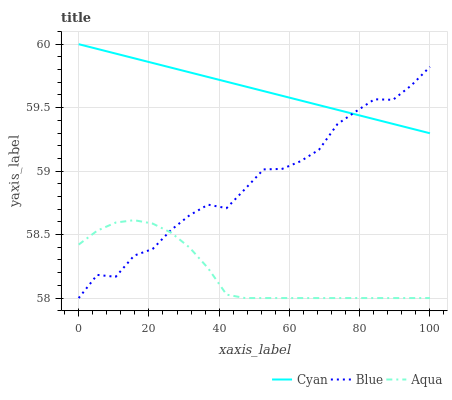Does Aqua have the minimum area under the curve?
Answer yes or no. Yes. Does Cyan have the maximum area under the curve?
Answer yes or no. Yes. Does Cyan have the minimum area under the curve?
Answer yes or no. No. Does Aqua have the maximum area under the curve?
Answer yes or no. No. Is Cyan the smoothest?
Answer yes or no. Yes. Is Blue the roughest?
Answer yes or no. Yes. Is Aqua the smoothest?
Answer yes or no. No. Is Aqua the roughest?
Answer yes or no. No. Does Blue have the lowest value?
Answer yes or no. Yes. Does Cyan have the lowest value?
Answer yes or no. No. Does Cyan have the highest value?
Answer yes or no. Yes. Does Aqua have the highest value?
Answer yes or no. No. Is Aqua less than Cyan?
Answer yes or no. Yes. Is Cyan greater than Aqua?
Answer yes or no. Yes. Does Aqua intersect Blue?
Answer yes or no. Yes. Is Aqua less than Blue?
Answer yes or no. No. Is Aqua greater than Blue?
Answer yes or no. No. Does Aqua intersect Cyan?
Answer yes or no. No. 